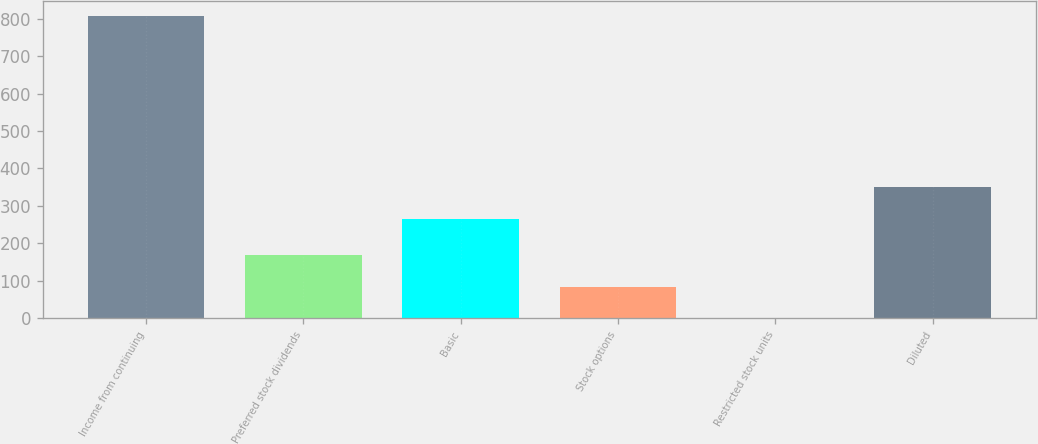Convert chart to OTSL. <chart><loc_0><loc_0><loc_500><loc_500><bar_chart><fcel>Income from continuing<fcel>Preferred stock dividends<fcel>Basic<fcel>Stock options<fcel>Restricted stock units<fcel>Diluted<nl><fcel>807.1<fcel>168.34<fcel>265.4<fcel>84.37<fcel>0.4<fcel>349.37<nl></chart> 